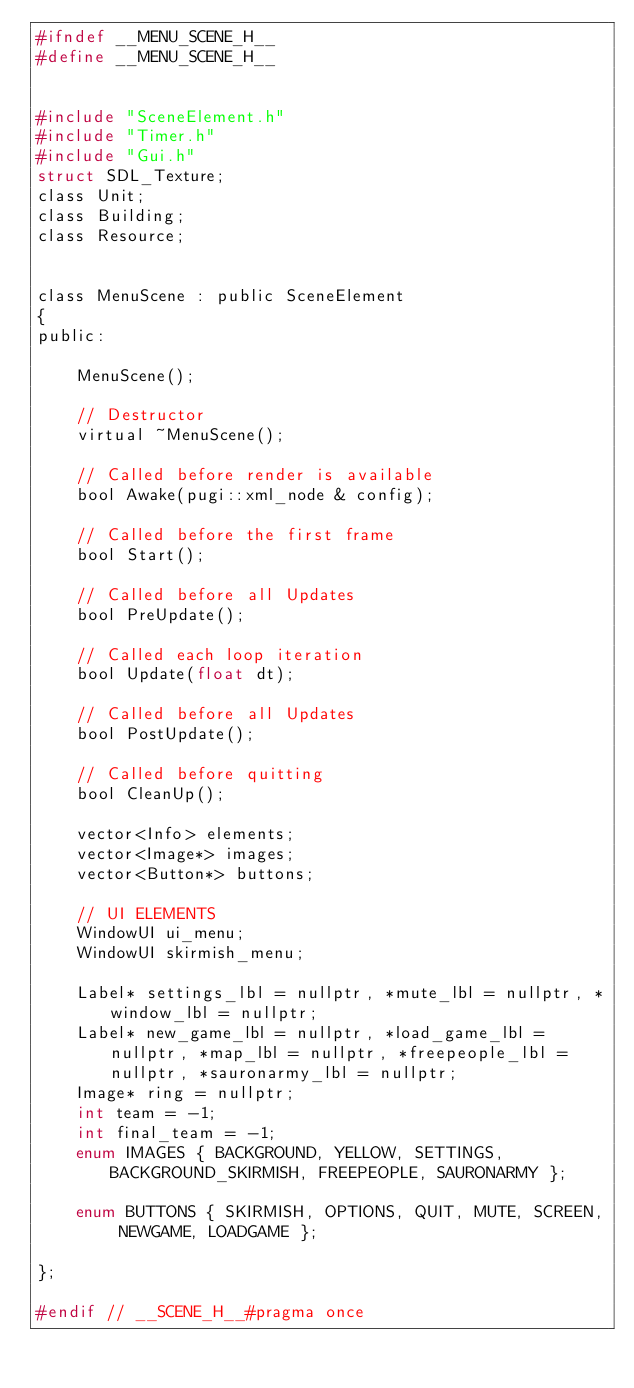Convert code to text. <code><loc_0><loc_0><loc_500><loc_500><_C_>#ifndef __MENU_SCENE_H__
#define __MENU_SCENE_H__


#include "SceneElement.h"
#include "Timer.h"
#include "Gui.h"
struct SDL_Texture;
class Unit;
class Building;
class Resource;


class MenuScene : public SceneElement
{
public:

	MenuScene();

	// Destructor
	virtual ~MenuScene();

	// Called before render is available
	bool Awake(pugi::xml_node & config);

	// Called before the first frame
	bool Start();

	// Called before all Updates
	bool PreUpdate();

	// Called each loop iteration
	bool Update(float dt);

	// Called before all Updates
	bool PostUpdate();

	// Called before quitting
	bool CleanUp();

	vector<Info> elements;
	vector<Image*> images;
	vector<Button*> buttons;

	// UI ELEMENTS
	WindowUI ui_menu;
	WindowUI skirmish_menu;

	Label* settings_lbl = nullptr, *mute_lbl = nullptr, *window_lbl = nullptr;
	Label* new_game_lbl = nullptr, *load_game_lbl = nullptr, *map_lbl = nullptr, *freepeople_lbl = nullptr, *sauronarmy_lbl = nullptr;
	Image* ring = nullptr;
	int team = -1;
	int final_team = -1;
	enum IMAGES { BACKGROUND, YELLOW, SETTINGS, BACKGROUND_SKIRMISH, FREEPEOPLE, SAURONARMY };

	enum BUTTONS { SKIRMISH, OPTIONS, QUIT, MUTE, SCREEN, NEWGAME, LOADGAME };

};

#endif // __SCENE_H__#pragma once

</code> 